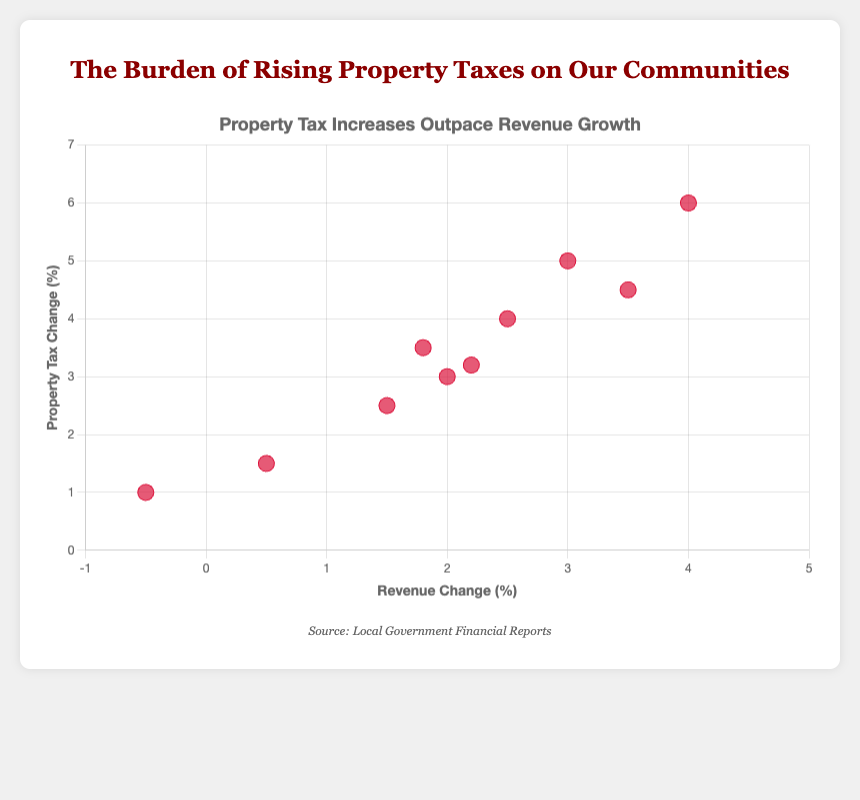Which city experienced the smallest increase in property tax? We need to look at the city with the lowest value of "Property Tax Change (%)". Greenville has the smallest increase in property tax at 1.0%.
Answer: Greenville Which city had the highest revenue change? We need to identify the city with the maximum value for "Revenue Change (%)". Hill Valley has the highest revenue change at 4.0%.
Answer: Hill Valley What's the difference in revenue change between Fairview and Kingsport? Fairview's revenue change is 3.5%, and Kingsport's is 0.5%. The difference would be 3.5% - 0.5% = 3.0%.
Answer: 3.0% How many cities have a revenue change above 2%? We need to count the cities where "Revenue Change (%)" is greater than 2%. The cities are Springfield, Centerville, Hill Valley, Fairview, and Laketown, totaling 5.
Answer: 5 Which city has the lowest revenue change and what is its property tax change? By finding the city with the lowest "Revenue Change (%)", which is Greenville at -0.5%. Greenville's property tax change is 1.0%.
Answer: Greenville, 1.0% Compare the revenue change and property tax change of Centerville and Bay City. Which city has a greater increase in both? Centerville has 3.0% revenue change and 5.0% property tax change. Bay City has 2.0% revenue change and 3.0% property tax change. Centerville has a greater increase in both metrics.
Answer: Centerville What is the average property tax change across all cities? Sum all "Property Tax Change (%)" values and divide by the number of cities. The values are 4.0, 3.5, 5.0, 1.0, 6.0, 2.5, 3.0, 1.5, 4.5, 3.2. The sum is 34.2, and the average is 34.2/10 = 3.42%.
Answer: 3.42% Is there any city where the revenue change is negative? If so, which one? We need to check if any city's "Revenue Change (%)" is less than 0. Greenville has a negative revenue change at -0.5%.
Answer: Greenville Between Springfield and Laketown, which city had a larger increase in property tax? Springfield's property tax change is 4.0%, and Laketown's property tax change is 3.2%. Springfield had a larger increase.
Answer: Springfield What is the median property tax change among the cities? Arrange the property tax changes in ascending order (1.0, 1.5, 2.5, 3.0, 3.2, 3.5, 4.0, 4.5, 5.0, 6.0). The median is the average of the middle two values (3.2 + 3.5)/2 = 3.35%.
Answer: 3.35% 